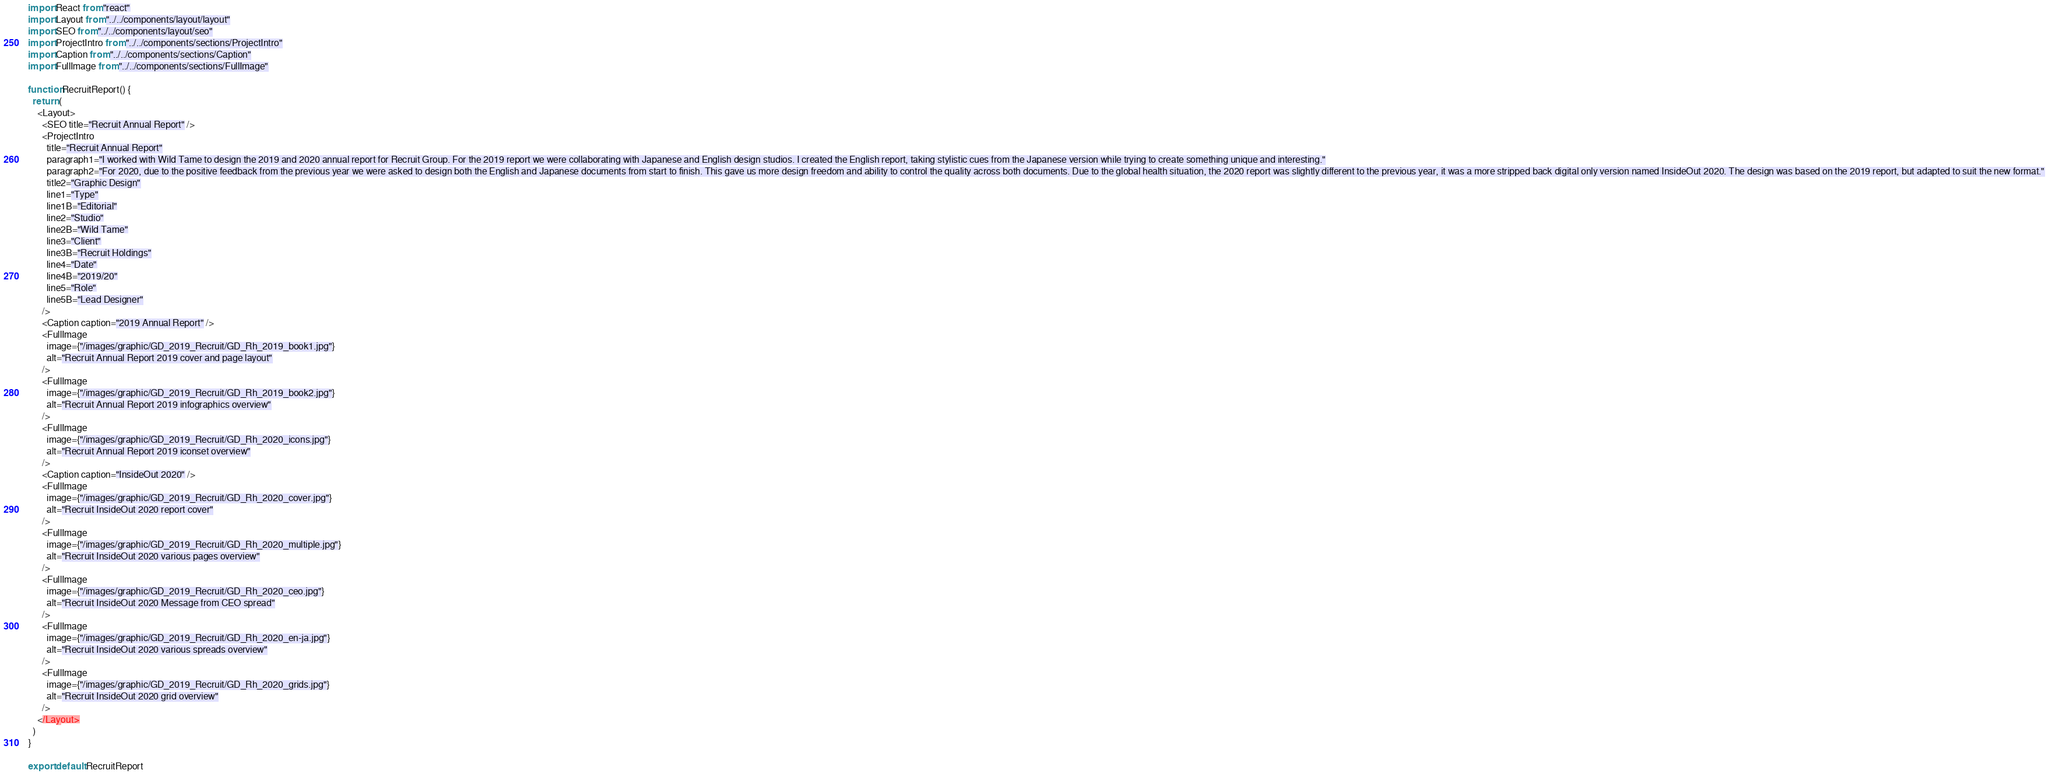<code> <loc_0><loc_0><loc_500><loc_500><_JavaScript_>import React from "react"
import Layout from "../../components/layout/layout"
import SEO from "../../components/layout/seo"
import ProjectIntro from "../../components/sections/ProjectIntro"
import Caption from "../../components/sections/Caption"
import FullImage from "../../components/sections/FullImage"

function RecruitReport() {
  return (
    <Layout>
      <SEO title="Recruit Annual Report" />
      <ProjectIntro
        title="Recruit Annual Report"
        paragraph1="I worked with Wild Tame to design the 2019 and 2020 annual report for Recruit Group. For the 2019 report we were collaborating with Japanese and English design studios. I created the English report, taking stylistic cues from the Japanese version while trying to create something unique and interesting."
        paragraph2="For 2020, due to the positive feedback from the previous year we were asked to design both the English and Japanese documents from start to finish. This gave us more design freedom and ability to control the quality across both documents. Due to the global health situation, the 2020 report was slightly different to the previous year, it was a more stripped back digital only version named InsideOut 2020. The design was based on the 2019 report, but adapted to suit the new format."
        title2="Graphic Design"
        line1="Type"
        line1B="Editorial"
        line2="Studio"
        line2B="Wild Tame"
        line3="Client"
        line3B="Recruit Holdings"
        line4="Date"
        line4B="2019/20"
        line5="Role"
        line5B="Lead Designer"
      />
      <Caption caption="2019 Annual Report" />
      <FullImage
        image={"/images/graphic/GD_2019_Recruit/GD_Rh_2019_book1.jpg"}
        alt="Recruit Annual Report 2019 cover and page layout"
      />
      <FullImage
        image={"/images/graphic/GD_2019_Recruit/GD_Rh_2019_book2.jpg"}
        alt="Recruit Annual Report 2019 infographics overview"
      />
      <FullImage
        image={"/images/graphic/GD_2019_Recruit/GD_Rh_2020_icons.jpg"}
        alt="Recruit Annual Report 2019 iconset overview"
      />
      <Caption caption="InsideOut 2020" />
      <FullImage
        image={"/images/graphic/GD_2019_Recruit/GD_Rh_2020_cover.jpg"}
        alt="Recruit InsideOut 2020 report cover"
      />
      <FullImage
        image={"/images/graphic/GD_2019_Recruit/GD_Rh_2020_multiple.jpg"}
        alt="Recruit InsideOut 2020 various pages overview"
      />
      <FullImage
        image={"/images/graphic/GD_2019_Recruit/GD_Rh_2020_ceo.jpg"}
        alt="Recruit InsideOut 2020 Message from CEO spread"
      />
      <FullImage
        image={"/images/graphic/GD_2019_Recruit/GD_Rh_2020_en-ja.jpg"}
        alt="Recruit InsideOut 2020 various spreads overview"
      />
      <FullImage
        image={"/images/graphic/GD_2019_Recruit/GD_Rh_2020_grids.jpg"}
        alt="Recruit InsideOut 2020 grid overview"
      />
    </Layout>
  )
}

export default RecruitReport
</code> 